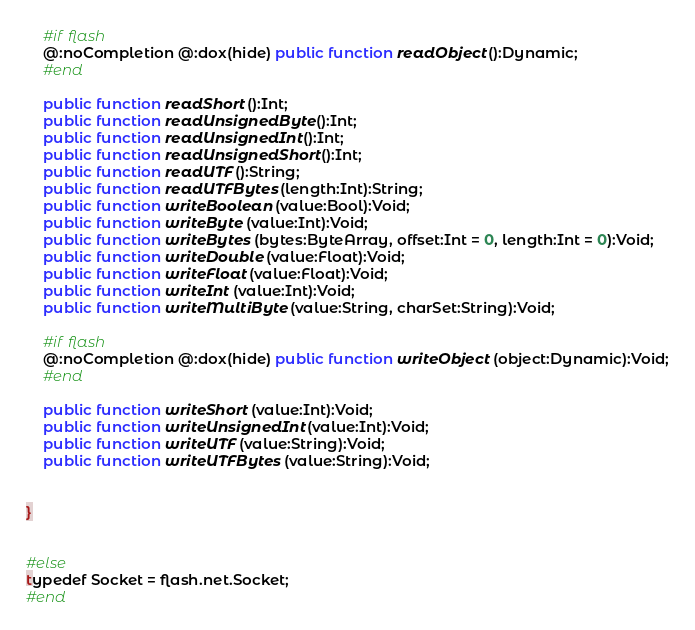<code> <loc_0><loc_0><loc_500><loc_500><_Haxe_>	#if flash
	@:noCompletion @:dox(hide) public function readObject ():Dynamic;
	#end
	
	public function readShort ():Int;
	public function readUnsignedByte ():Int;
	public function readUnsignedInt ():Int;
	public function readUnsignedShort ():Int;
	public function readUTF ():String;
	public function readUTFBytes (length:Int):String;
	public function writeBoolean (value:Bool):Void;
	public function writeByte (value:Int):Void;
	public function writeBytes (bytes:ByteArray, offset:Int = 0, length:Int = 0):Void;
	public function writeDouble (value:Float):Void;
	public function writeFloat (value:Float):Void;
	public function writeInt (value:Int):Void;
	public function writeMultiByte (value:String, charSet:String):Void;
	
	#if flash
	@:noCompletion @:dox(hide) public function writeObject (object:Dynamic):Void;
	#end
	
	public function writeShort (value:Int):Void;
	public function writeUnsignedInt (value:Int):Void;
	public function writeUTF (value:String):Void;
	public function writeUTFBytes (value:String):Void;
	
	
}


#else
typedef Socket = flash.net.Socket;
#end
</code> 